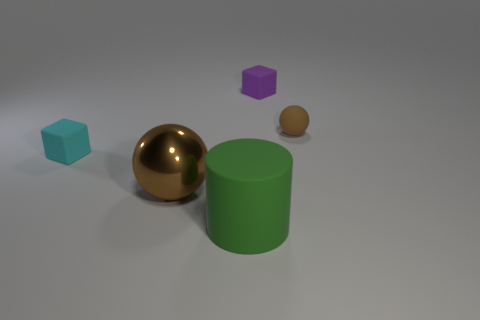Could you tell me how the lighting affects the appearance of these objects? The lighting in the image creates a soft and diffused effect with gentle shadows, which emphasizes the matte texture of the green cylinder and the teal cube. In contrast, the gold sphere reflects the light brilliantly, highlighting its glossy and reflective surface. The brown sphere, while also glossy, has a subtler reflection due to its darker color. The purple cube's small size and matte finish make it the least reflective, with soft-edged shadows underscoring its presence in the scene. 